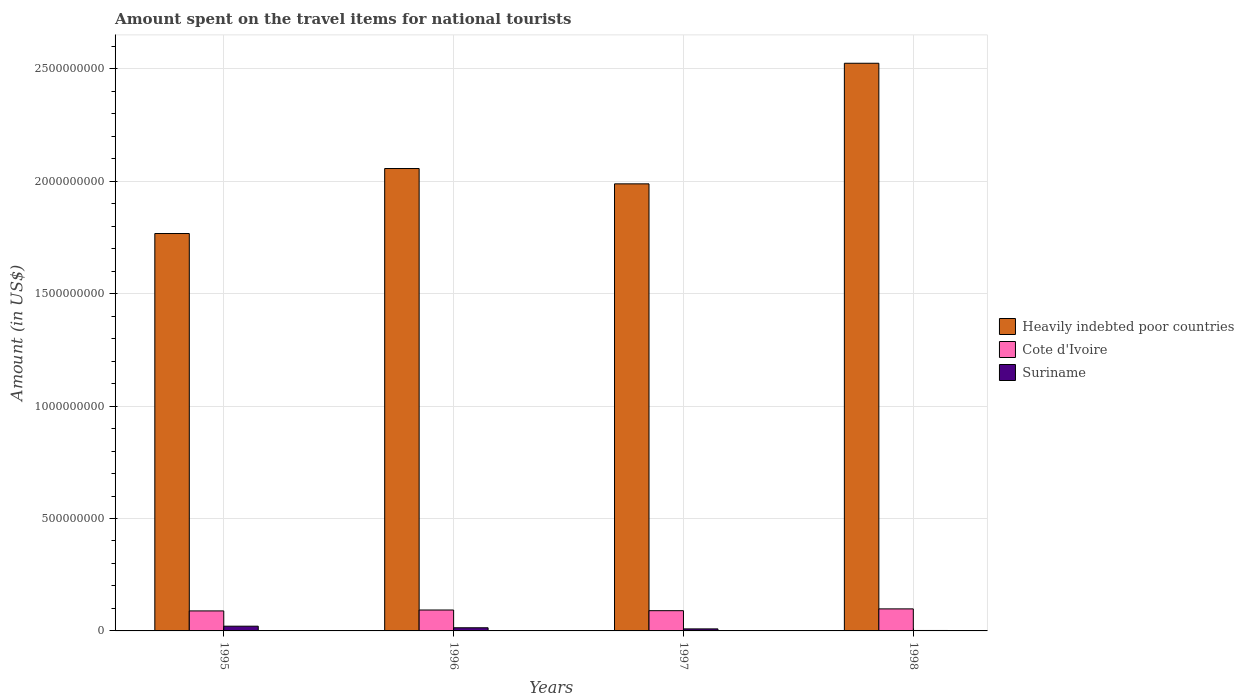Are the number of bars per tick equal to the number of legend labels?
Make the answer very short. Yes. Are the number of bars on each tick of the X-axis equal?
Offer a terse response. Yes. How many bars are there on the 2nd tick from the left?
Provide a short and direct response. 3. In how many cases, is the number of bars for a given year not equal to the number of legend labels?
Provide a short and direct response. 0. What is the amount spent on the travel items for national tourists in Heavily indebted poor countries in 1998?
Your answer should be compact. 2.52e+09. Across all years, what is the maximum amount spent on the travel items for national tourists in Cote d'Ivoire?
Your answer should be compact. 9.80e+07. Across all years, what is the minimum amount spent on the travel items for national tourists in Heavily indebted poor countries?
Make the answer very short. 1.77e+09. In which year was the amount spent on the travel items for national tourists in Suriname maximum?
Your answer should be very brief. 1995. What is the total amount spent on the travel items for national tourists in Cote d'Ivoire in the graph?
Make the answer very short. 3.70e+08. What is the difference between the amount spent on the travel items for national tourists in Suriname in 1995 and that in 1996?
Keep it short and to the point. 7.00e+06. What is the difference between the amount spent on the travel items for national tourists in Cote d'Ivoire in 1998 and the amount spent on the travel items for national tourists in Heavily indebted poor countries in 1995?
Make the answer very short. -1.67e+09. What is the average amount spent on the travel items for national tourists in Cote d'Ivoire per year?
Make the answer very short. 9.25e+07. In the year 1997, what is the difference between the amount spent on the travel items for national tourists in Suriname and amount spent on the travel items for national tourists in Cote d'Ivoire?
Your answer should be compact. -8.10e+07. What is the ratio of the amount spent on the travel items for national tourists in Cote d'Ivoire in 1995 to that in 1996?
Your answer should be very brief. 0.96. Is the amount spent on the travel items for national tourists in Suriname in 1997 less than that in 1998?
Your answer should be compact. No. What is the difference between the highest and the second highest amount spent on the travel items for national tourists in Heavily indebted poor countries?
Your response must be concise. 4.68e+08. What is the difference between the highest and the lowest amount spent on the travel items for national tourists in Cote d'Ivoire?
Your answer should be very brief. 9.00e+06. What does the 3rd bar from the left in 1998 represents?
Keep it short and to the point. Suriname. What does the 2nd bar from the right in 1996 represents?
Your answer should be very brief. Cote d'Ivoire. How many years are there in the graph?
Ensure brevity in your answer.  4. What is the difference between two consecutive major ticks on the Y-axis?
Give a very brief answer. 5.00e+08. Does the graph contain any zero values?
Ensure brevity in your answer.  No. How many legend labels are there?
Your answer should be very brief. 3. How are the legend labels stacked?
Your response must be concise. Vertical. What is the title of the graph?
Ensure brevity in your answer.  Amount spent on the travel items for national tourists. Does "Cambodia" appear as one of the legend labels in the graph?
Ensure brevity in your answer.  No. What is the label or title of the X-axis?
Give a very brief answer. Years. What is the Amount (in US$) in Heavily indebted poor countries in 1995?
Provide a succinct answer. 1.77e+09. What is the Amount (in US$) in Cote d'Ivoire in 1995?
Give a very brief answer. 8.90e+07. What is the Amount (in US$) of Suriname in 1995?
Your response must be concise. 2.10e+07. What is the Amount (in US$) in Heavily indebted poor countries in 1996?
Your answer should be very brief. 2.06e+09. What is the Amount (in US$) of Cote d'Ivoire in 1996?
Offer a very short reply. 9.30e+07. What is the Amount (in US$) of Suriname in 1996?
Make the answer very short. 1.40e+07. What is the Amount (in US$) of Heavily indebted poor countries in 1997?
Keep it short and to the point. 1.99e+09. What is the Amount (in US$) of Cote d'Ivoire in 1997?
Provide a succinct answer. 9.00e+07. What is the Amount (in US$) in Suriname in 1997?
Provide a short and direct response. 9.00e+06. What is the Amount (in US$) of Heavily indebted poor countries in 1998?
Your answer should be compact. 2.52e+09. What is the Amount (in US$) in Cote d'Ivoire in 1998?
Your response must be concise. 9.80e+07. Across all years, what is the maximum Amount (in US$) of Heavily indebted poor countries?
Keep it short and to the point. 2.52e+09. Across all years, what is the maximum Amount (in US$) of Cote d'Ivoire?
Ensure brevity in your answer.  9.80e+07. Across all years, what is the maximum Amount (in US$) of Suriname?
Provide a short and direct response. 2.10e+07. Across all years, what is the minimum Amount (in US$) of Heavily indebted poor countries?
Keep it short and to the point. 1.77e+09. Across all years, what is the minimum Amount (in US$) in Cote d'Ivoire?
Provide a short and direct response. 8.90e+07. What is the total Amount (in US$) in Heavily indebted poor countries in the graph?
Offer a very short reply. 8.34e+09. What is the total Amount (in US$) of Cote d'Ivoire in the graph?
Keep it short and to the point. 3.70e+08. What is the total Amount (in US$) in Suriname in the graph?
Your answer should be very brief. 4.60e+07. What is the difference between the Amount (in US$) in Heavily indebted poor countries in 1995 and that in 1996?
Provide a succinct answer. -2.89e+08. What is the difference between the Amount (in US$) of Suriname in 1995 and that in 1996?
Make the answer very short. 7.00e+06. What is the difference between the Amount (in US$) of Heavily indebted poor countries in 1995 and that in 1997?
Ensure brevity in your answer.  -2.21e+08. What is the difference between the Amount (in US$) of Heavily indebted poor countries in 1995 and that in 1998?
Your answer should be compact. -7.57e+08. What is the difference between the Amount (in US$) of Cote d'Ivoire in 1995 and that in 1998?
Keep it short and to the point. -9.00e+06. What is the difference between the Amount (in US$) in Suriname in 1995 and that in 1998?
Provide a short and direct response. 1.90e+07. What is the difference between the Amount (in US$) of Heavily indebted poor countries in 1996 and that in 1997?
Ensure brevity in your answer.  6.82e+07. What is the difference between the Amount (in US$) of Heavily indebted poor countries in 1996 and that in 1998?
Make the answer very short. -4.68e+08. What is the difference between the Amount (in US$) of Cote d'Ivoire in 1996 and that in 1998?
Give a very brief answer. -5.00e+06. What is the difference between the Amount (in US$) of Heavily indebted poor countries in 1997 and that in 1998?
Offer a terse response. -5.36e+08. What is the difference between the Amount (in US$) of Cote d'Ivoire in 1997 and that in 1998?
Your answer should be very brief. -8.00e+06. What is the difference between the Amount (in US$) of Suriname in 1997 and that in 1998?
Provide a succinct answer. 7.00e+06. What is the difference between the Amount (in US$) of Heavily indebted poor countries in 1995 and the Amount (in US$) of Cote d'Ivoire in 1996?
Keep it short and to the point. 1.67e+09. What is the difference between the Amount (in US$) of Heavily indebted poor countries in 1995 and the Amount (in US$) of Suriname in 1996?
Your answer should be very brief. 1.75e+09. What is the difference between the Amount (in US$) in Cote d'Ivoire in 1995 and the Amount (in US$) in Suriname in 1996?
Make the answer very short. 7.50e+07. What is the difference between the Amount (in US$) of Heavily indebted poor countries in 1995 and the Amount (in US$) of Cote d'Ivoire in 1997?
Offer a terse response. 1.68e+09. What is the difference between the Amount (in US$) of Heavily indebted poor countries in 1995 and the Amount (in US$) of Suriname in 1997?
Make the answer very short. 1.76e+09. What is the difference between the Amount (in US$) of Cote d'Ivoire in 1995 and the Amount (in US$) of Suriname in 1997?
Provide a short and direct response. 8.00e+07. What is the difference between the Amount (in US$) of Heavily indebted poor countries in 1995 and the Amount (in US$) of Cote d'Ivoire in 1998?
Keep it short and to the point. 1.67e+09. What is the difference between the Amount (in US$) in Heavily indebted poor countries in 1995 and the Amount (in US$) in Suriname in 1998?
Ensure brevity in your answer.  1.77e+09. What is the difference between the Amount (in US$) in Cote d'Ivoire in 1995 and the Amount (in US$) in Suriname in 1998?
Your answer should be very brief. 8.70e+07. What is the difference between the Amount (in US$) in Heavily indebted poor countries in 1996 and the Amount (in US$) in Cote d'Ivoire in 1997?
Offer a very short reply. 1.97e+09. What is the difference between the Amount (in US$) of Heavily indebted poor countries in 1996 and the Amount (in US$) of Suriname in 1997?
Your answer should be compact. 2.05e+09. What is the difference between the Amount (in US$) in Cote d'Ivoire in 1996 and the Amount (in US$) in Suriname in 1997?
Ensure brevity in your answer.  8.40e+07. What is the difference between the Amount (in US$) in Heavily indebted poor countries in 1996 and the Amount (in US$) in Cote d'Ivoire in 1998?
Your answer should be compact. 1.96e+09. What is the difference between the Amount (in US$) of Heavily indebted poor countries in 1996 and the Amount (in US$) of Suriname in 1998?
Give a very brief answer. 2.05e+09. What is the difference between the Amount (in US$) of Cote d'Ivoire in 1996 and the Amount (in US$) of Suriname in 1998?
Your answer should be very brief. 9.10e+07. What is the difference between the Amount (in US$) of Heavily indebted poor countries in 1997 and the Amount (in US$) of Cote d'Ivoire in 1998?
Provide a short and direct response. 1.89e+09. What is the difference between the Amount (in US$) of Heavily indebted poor countries in 1997 and the Amount (in US$) of Suriname in 1998?
Keep it short and to the point. 1.99e+09. What is the difference between the Amount (in US$) of Cote d'Ivoire in 1997 and the Amount (in US$) of Suriname in 1998?
Provide a short and direct response. 8.80e+07. What is the average Amount (in US$) in Heavily indebted poor countries per year?
Your response must be concise. 2.08e+09. What is the average Amount (in US$) of Cote d'Ivoire per year?
Give a very brief answer. 9.25e+07. What is the average Amount (in US$) of Suriname per year?
Keep it short and to the point. 1.15e+07. In the year 1995, what is the difference between the Amount (in US$) of Heavily indebted poor countries and Amount (in US$) of Cote d'Ivoire?
Provide a succinct answer. 1.68e+09. In the year 1995, what is the difference between the Amount (in US$) in Heavily indebted poor countries and Amount (in US$) in Suriname?
Provide a short and direct response. 1.75e+09. In the year 1995, what is the difference between the Amount (in US$) in Cote d'Ivoire and Amount (in US$) in Suriname?
Make the answer very short. 6.80e+07. In the year 1996, what is the difference between the Amount (in US$) of Heavily indebted poor countries and Amount (in US$) of Cote d'Ivoire?
Give a very brief answer. 1.96e+09. In the year 1996, what is the difference between the Amount (in US$) of Heavily indebted poor countries and Amount (in US$) of Suriname?
Ensure brevity in your answer.  2.04e+09. In the year 1996, what is the difference between the Amount (in US$) in Cote d'Ivoire and Amount (in US$) in Suriname?
Your answer should be compact. 7.90e+07. In the year 1997, what is the difference between the Amount (in US$) in Heavily indebted poor countries and Amount (in US$) in Cote d'Ivoire?
Your response must be concise. 1.90e+09. In the year 1997, what is the difference between the Amount (in US$) in Heavily indebted poor countries and Amount (in US$) in Suriname?
Offer a terse response. 1.98e+09. In the year 1997, what is the difference between the Amount (in US$) of Cote d'Ivoire and Amount (in US$) of Suriname?
Your answer should be very brief. 8.10e+07. In the year 1998, what is the difference between the Amount (in US$) of Heavily indebted poor countries and Amount (in US$) of Cote d'Ivoire?
Ensure brevity in your answer.  2.43e+09. In the year 1998, what is the difference between the Amount (in US$) of Heavily indebted poor countries and Amount (in US$) of Suriname?
Make the answer very short. 2.52e+09. In the year 1998, what is the difference between the Amount (in US$) in Cote d'Ivoire and Amount (in US$) in Suriname?
Provide a succinct answer. 9.60e+07. What is the ratio of the Amount (in US$) of Heavily indebted poor countries in 1995 to that in 1996?
Provide a short and direct response. 0.86. What is the ratio of the Amount (in US$) in Cote d'Ivoire in 1995 to that in 1996?
Offer a terse response. 0.96. What is the ratio of the Amount (in US$) in Heavily indebted poor countries in 1995 to that in 1997?
Provide a short and direct response. 0.89. What is the ratio of the Amount (in US$) in Cote d'Ivoire in 1995 to that in 1997?
Give a very brief answer. 0.99. What is the ratio of the Amount (in US$) in Suriname in 1995 to that in 1997?
Ensure brevity in your answer.  2.33. What is the ratio of the Amount (in US$) in Heavily indebted poor countries in 1995 to that in 1998?
Your answer should be very brief. 0.7. What is the ratio of the Amount (in US$) in Cote d'Ivoire in 1995 to that in 1998?
Give a very brief answer. 0.91. What is the ratio of the Amount (in US$) in Suriname in 1995 to that in 1998?
Provide a succinct answer. 10.5. What is the ratio of the Amount (in US$) of Heavily indebted poor countries in 1996 to that in 1997?
Provide a short and direct response. 1.03. What is the ratio of the Amount (in US$) in Suriname in 1996 to that in 1997?
Provide a short and direct response. 1.56. What is the ratio of the Amount (in US$) in Heavily indebted poor countries in 1996 to that in 1998?
Your answer should be compact. 0.81. What is the ratio of the Amount (in US$) of Cote d'Ivoire in 1996 to that in 1998?
Provide a succinct answer. 0.95. What is the ratio of the Amount (in US$) in Suriname in 1996 to that in 1998?
Provide a short and direct response. 7. What is the ratio of the Amount (in US$) in Heavily indebted poor countries in 1997 to that in 1998?
Your answer should be compact. 0.79. What is the ratio of the Amount (in US$) in Cote d'Ivoire in 1997 to that in 1998?
Keep it short and to the point. 0.92. What is the ratio of the Amount (in US$) of Suriname in 1997 to that in 1998?
Offer a terse response. 4.5. What is the difference between the highest and the second highest Amount (in US$) in Heavily indebted poor countries?
Your response must be concise. 4.68e+08. What is the difference between the highest and the second highest Amount (in US$) of Suriname?
Give a very brief answer. 7.00e+06. What is the difference between the highest and the lowest Amount (in US$) in Heavily indebted poor countries?
Your response must be concise. 7.57e+08. What is the difference between the highest and the lowest Amount (in US$) of Cote d'Ivoire?
Provide a short and direct response. 9.00e+06. What is the difference between the highest and the lowest Amount (in US$) of Suriname?
Offer a very short reply. 1.90e+07. 